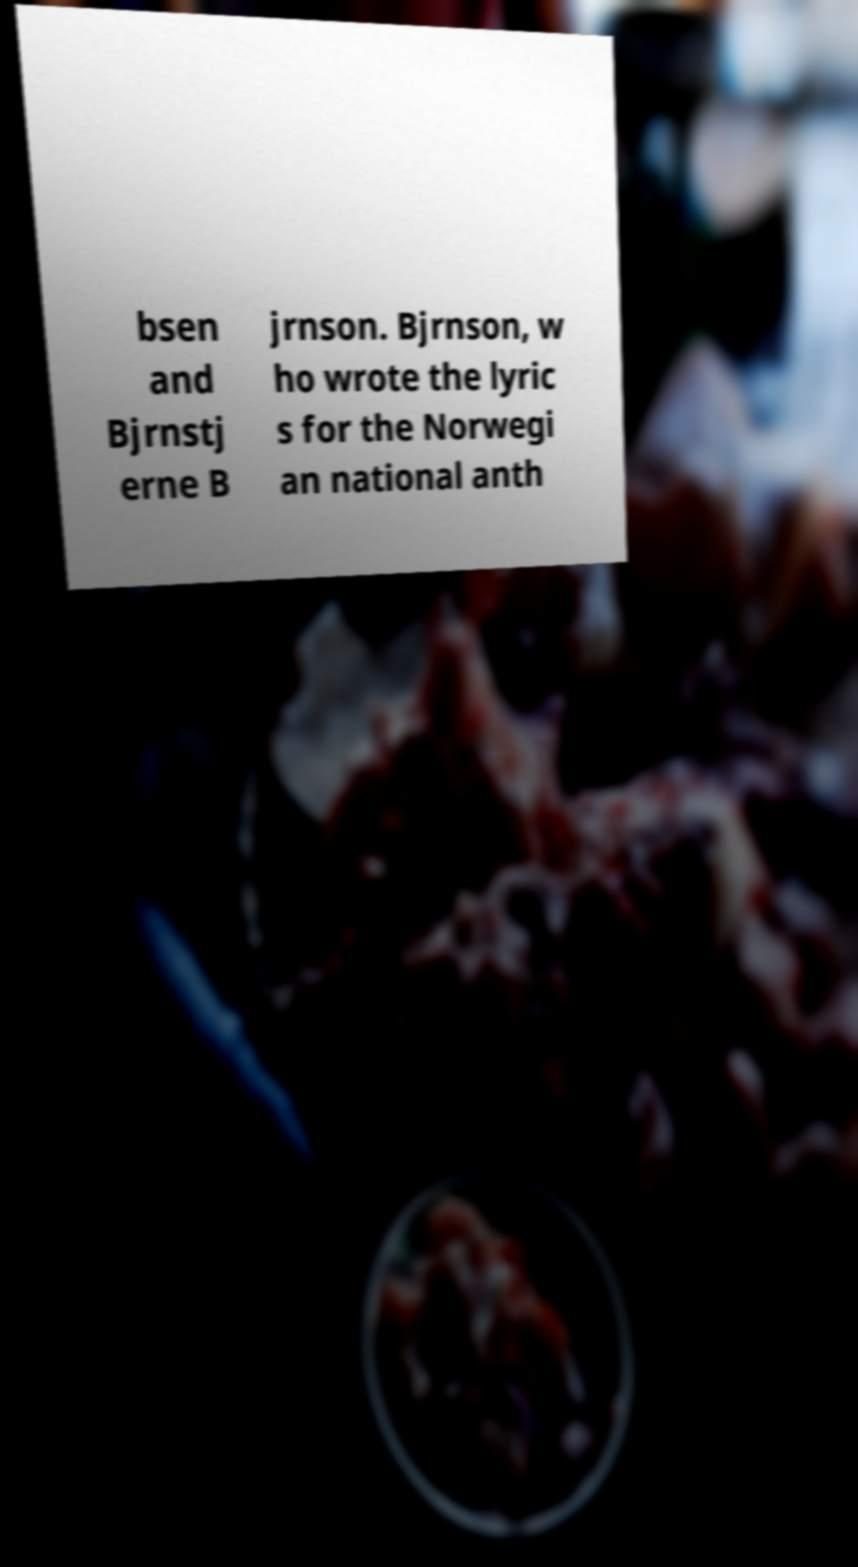Can you read and provide the text displayed in the image?This photo seems to have some interesting text. Can you extract and type it out for me? bsen and Bjrnstj erne B jrnson. Bjrnson, w ho wrote the lyric s for the Norwegi an national anth 